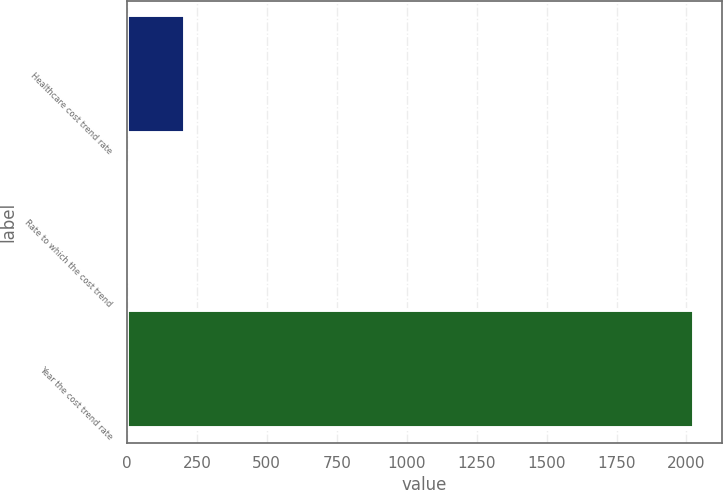Convert chart to OTSL. <chart><loc_0><loc_0><loc_500><loc_500><bar_chart><fcel>Healthcare cost trend rate<fcel>Rate to which the cost trend<fcel>Year the cost trend rate<nl><fcel>206.75<fcel>4.5<fcel>2027<nl></chart> 